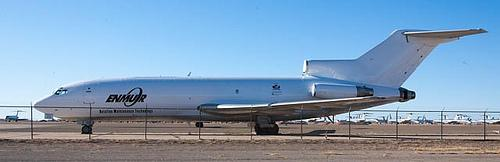Write a detailed image caption for a social media post. "The White Beauty: A magnificent airplane parked on the tarmac, with its landing gear, black logo and lettering, and tail fin ready for takeoff under a cloudless blue sky! ✈️🌞" Provide a concise description of the key elements within the image. White airplane on tarmac, black logo and lettering, tail fin, landing gear, blue sky, metal fence, dead grass, and asphalt road. Describe the scene captured in the image using a poetic language style. An ethereal blue sky embraces the gleaming white plane, humbly stationed amidst dead grass and the security of a metallic fence. Imagine you are a tour guide, and describe the image to your group of tourists. Ladies and gentlemen, this lovely image showcases a large white airplane, adorned with black logo and lettering, resting on the tarmac and surrounded by both a metal fence and the calming hues of a bright blue sky. Give a one-sentence summary of the contents of the image. The image shows a white airplane with black logo and lettering on the ground, surrounded by a fence, asphalt, and dead grass beneath a blue sky. List the noteworthy features of the plane seen in the image. White color, black logo, black lettering, tail fin, landing gear, part of a wing, on the ground, edge visible. Write an image description for a travel blog post. Captured on a clear day, our photo spotlights a striking white aircraft, standing proudly on the black asphalt and safely enclosed by a metal fence. Describe the environment surrounding the main object in the image. The airplane is surrounded by a grey metal fence, dead brown grass, black asphalt road, and a vast blue sky above. Mention the colors and distinctive features of the primary object in the image. The main object is a white airplane with black logo, black lettering, a white tail fin, and visible landing gear. Write a brief description of the image for a news article. A white plane, featuring black logo and lettering, is parked on the tarmac, surrounded by a chain-link fence, with a clear blue sky overhead. 